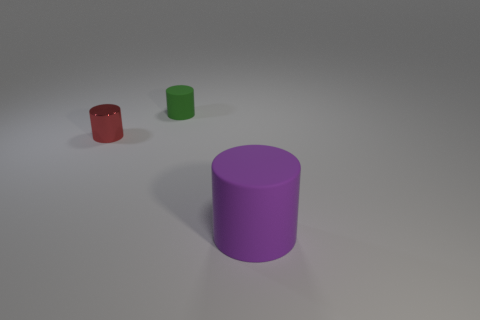What is the shape of the other object that is the same material as the large purple thing?
Offer a very short reply. Cylinder. Do the green matte cylinder and the purple cylinder have the same size?
Keep it short and to the point. No. There is a matte thing that is behind the cylinder to the right of the small green cylinder; what size is it?
Offer a very short reply. Small. What number of cubes are either tiny green objects or purple shiny objects?
Make the answer very short. 0. There is a metal cylinder; is its size the same as the object behind the tiny red thing?
Give a very brief answer. Yes. Is the number of cylinders that are behind the small red shiny cylinder greater than the number of big brown rubber cubes?
Your answer should be very brief. Yes. What is the size of the green cylinder that is the same material as the big thing?
Your answer should be compact. Small. Are there any matte things of the same color as the small shiny cylinder?
Ensure brevity in your answer.  No. What number of objects are tiny green objects or things that are on the right side of the tiny rubber thing?
Offer a very short reply. 2. Is the number of purple rubber things greater than the number of cyan metal blocks?
Offer a terse response. Yes. 